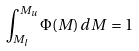Convert formula to latex. <formula><loc_0><loc_0><loc_500><loc_500>\int _ { M _ { l } } ^ { M _ { u } } \Phi ( M ) \, d M \, = 1</formula> 